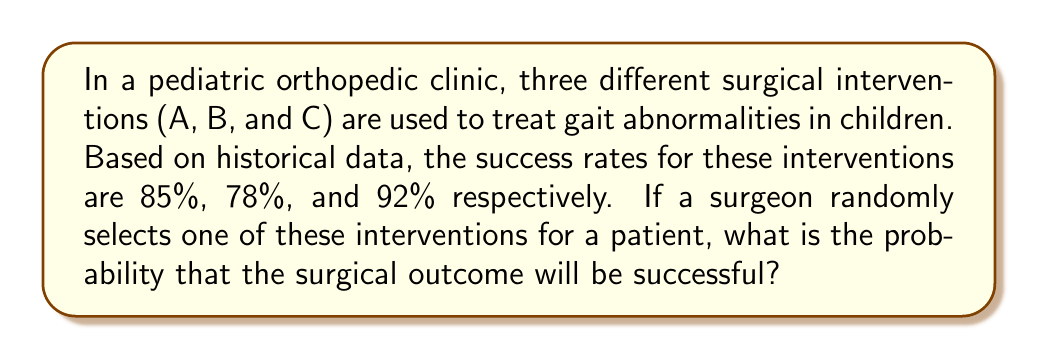Solve this math problem. To solve this problem, we need to use the concept of total probability. Let's break it down step by step:

1) First, we need to calculate the probability of selecting each intervention. Since the selection is random and there are three interventions, the probability of selecting each is $\frac{1}{3}$.

2) Now, let's define our events:
   S: The surgical outcome is successful
   A: Intervention A is selected
   B: Intervention B is selected
   C: Intervention C is selected

3) We can express the probability of success as:

   $$P(S) = P(S|A)P(A) + P(S|B)P(B) + P(S|C)P(C)$$

   Where:
   $P(S|A)$ is the probability of success given that intervention A was chosen
   $P(A)$ is the probability of choosing intervention A
   (and similarly for B and C)

4) Now, let's substitute the values:

   $$P(S) = 0.85 \cdot \frac{1}{3} + 0.78 \cdot \frac{1}{3} + 0.92 \cdot \frac{1}{3}$$

5) Simplify:

   $$P(S) = \frac{0.85 + 0.78 + 0.92}{3} = \frac{2.55}{3} = 0.85$$

Therefore, the probability of a successful surgical outcome when randomly selecting one of the three interventions is 0.85 or 85%.
Answer: 0.85 or 85% 